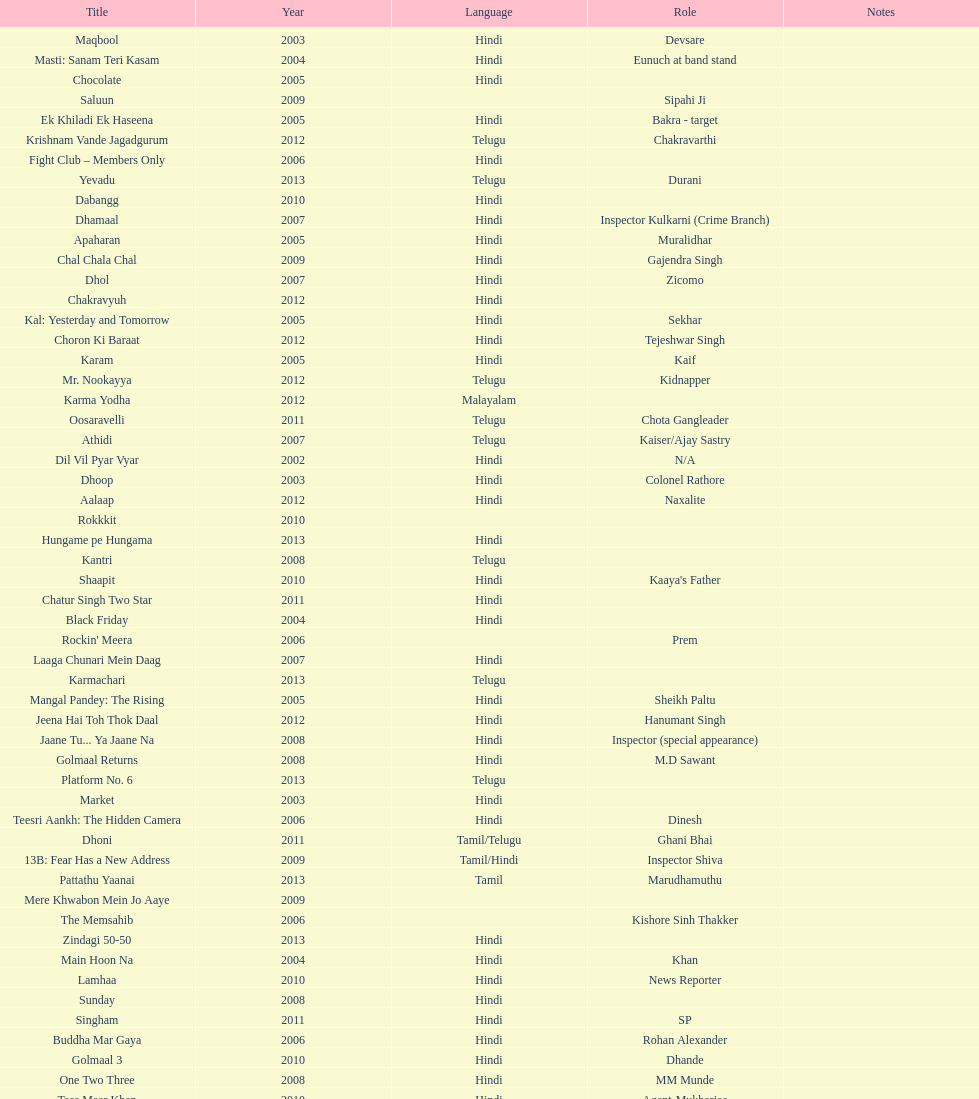What movie did this actor star in after they starred in dil vil pyar vyar in 2002? Maqbool. 